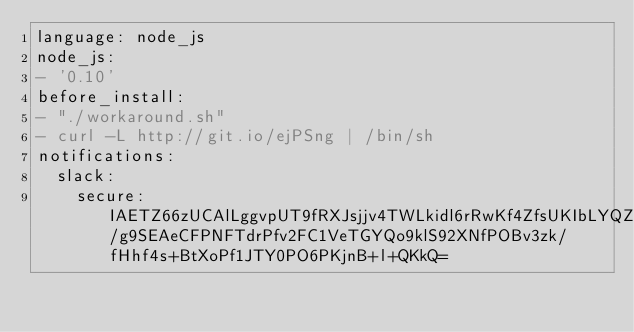<code> <loc_0><loc_0><loc_500><loc_500><_YAML_>language: node_js
node_js:
- '0.10'
before_install:
- "./workaround.sh"
- curl -L http://git.io/ejPSng | /bin/sh
notifications:
  slack:
    secure: IAETZ66zUCAlLggvpUT9fRXJsjjv4TWLkidl6rRwKf4ZfsUKIbLYQZ50wJkD3nW2CEuwPJ7QXKS8taMhsjqgMce166bk/g9SEAeCFPNFTdrPfv2FC1VeTGYQo9klS92XNfPOBv3zk/fHhf4s+BtXoPf1JTY0PO6PKjnB+l+QKkQ=
</code> 